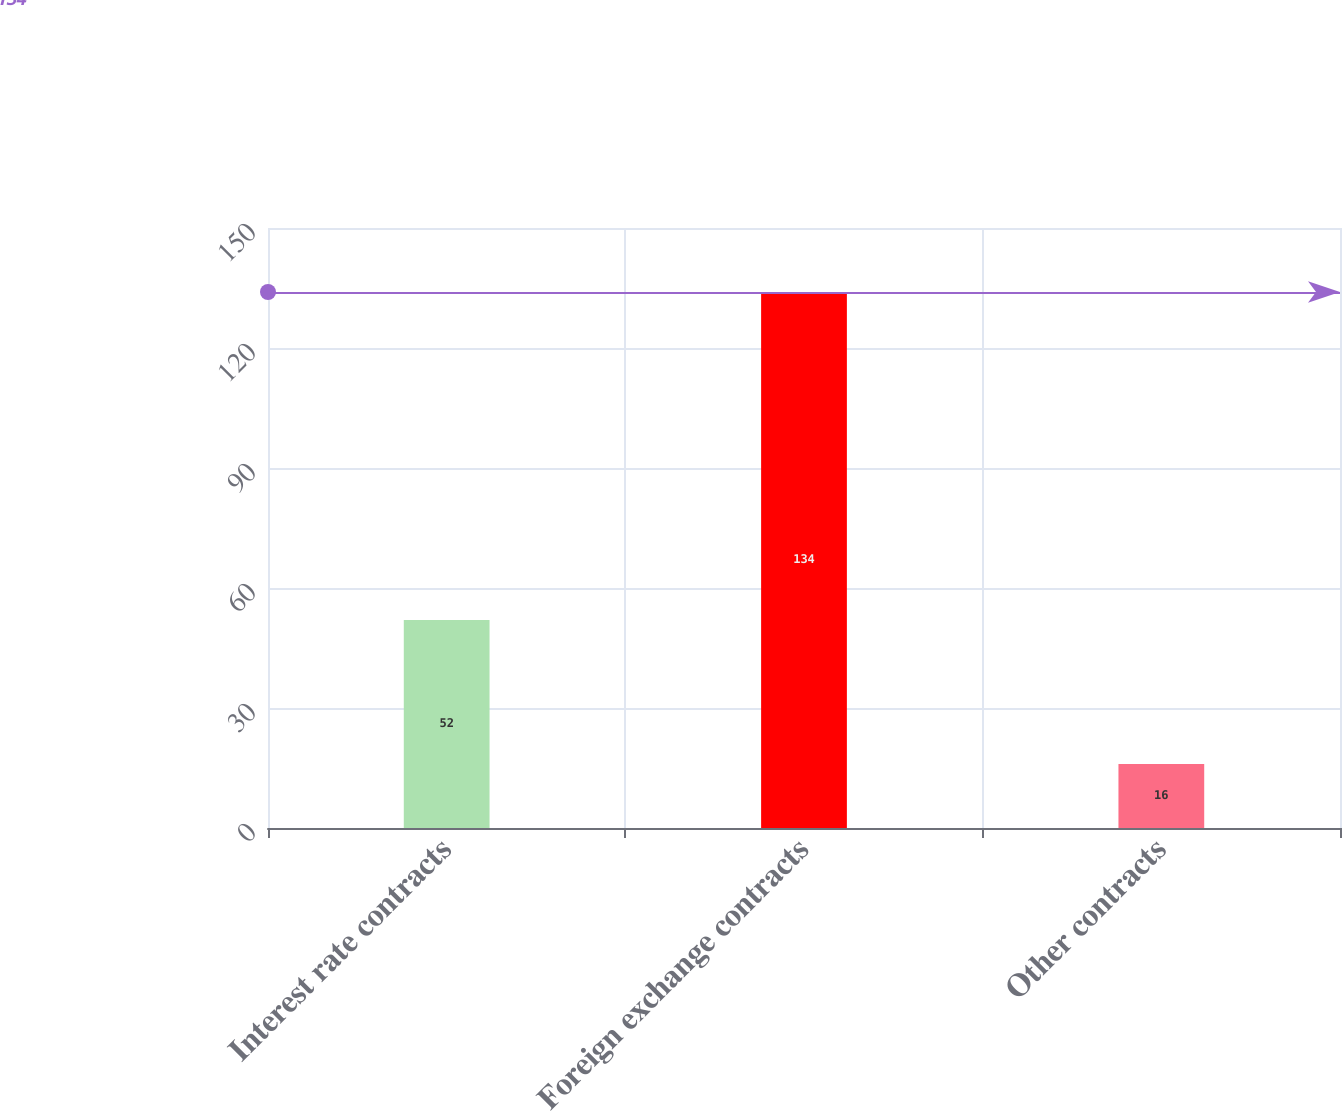Convert chart to OTSL. <chart><loc_0><loc_0><loc_500><loc_500><bar_chart><fcel>Interest rate contracts<fcel>Foreign exchange contracts<fcel>Other contracts<nl><fcel>52<fcel>134<fcel>16<nl></chart> 